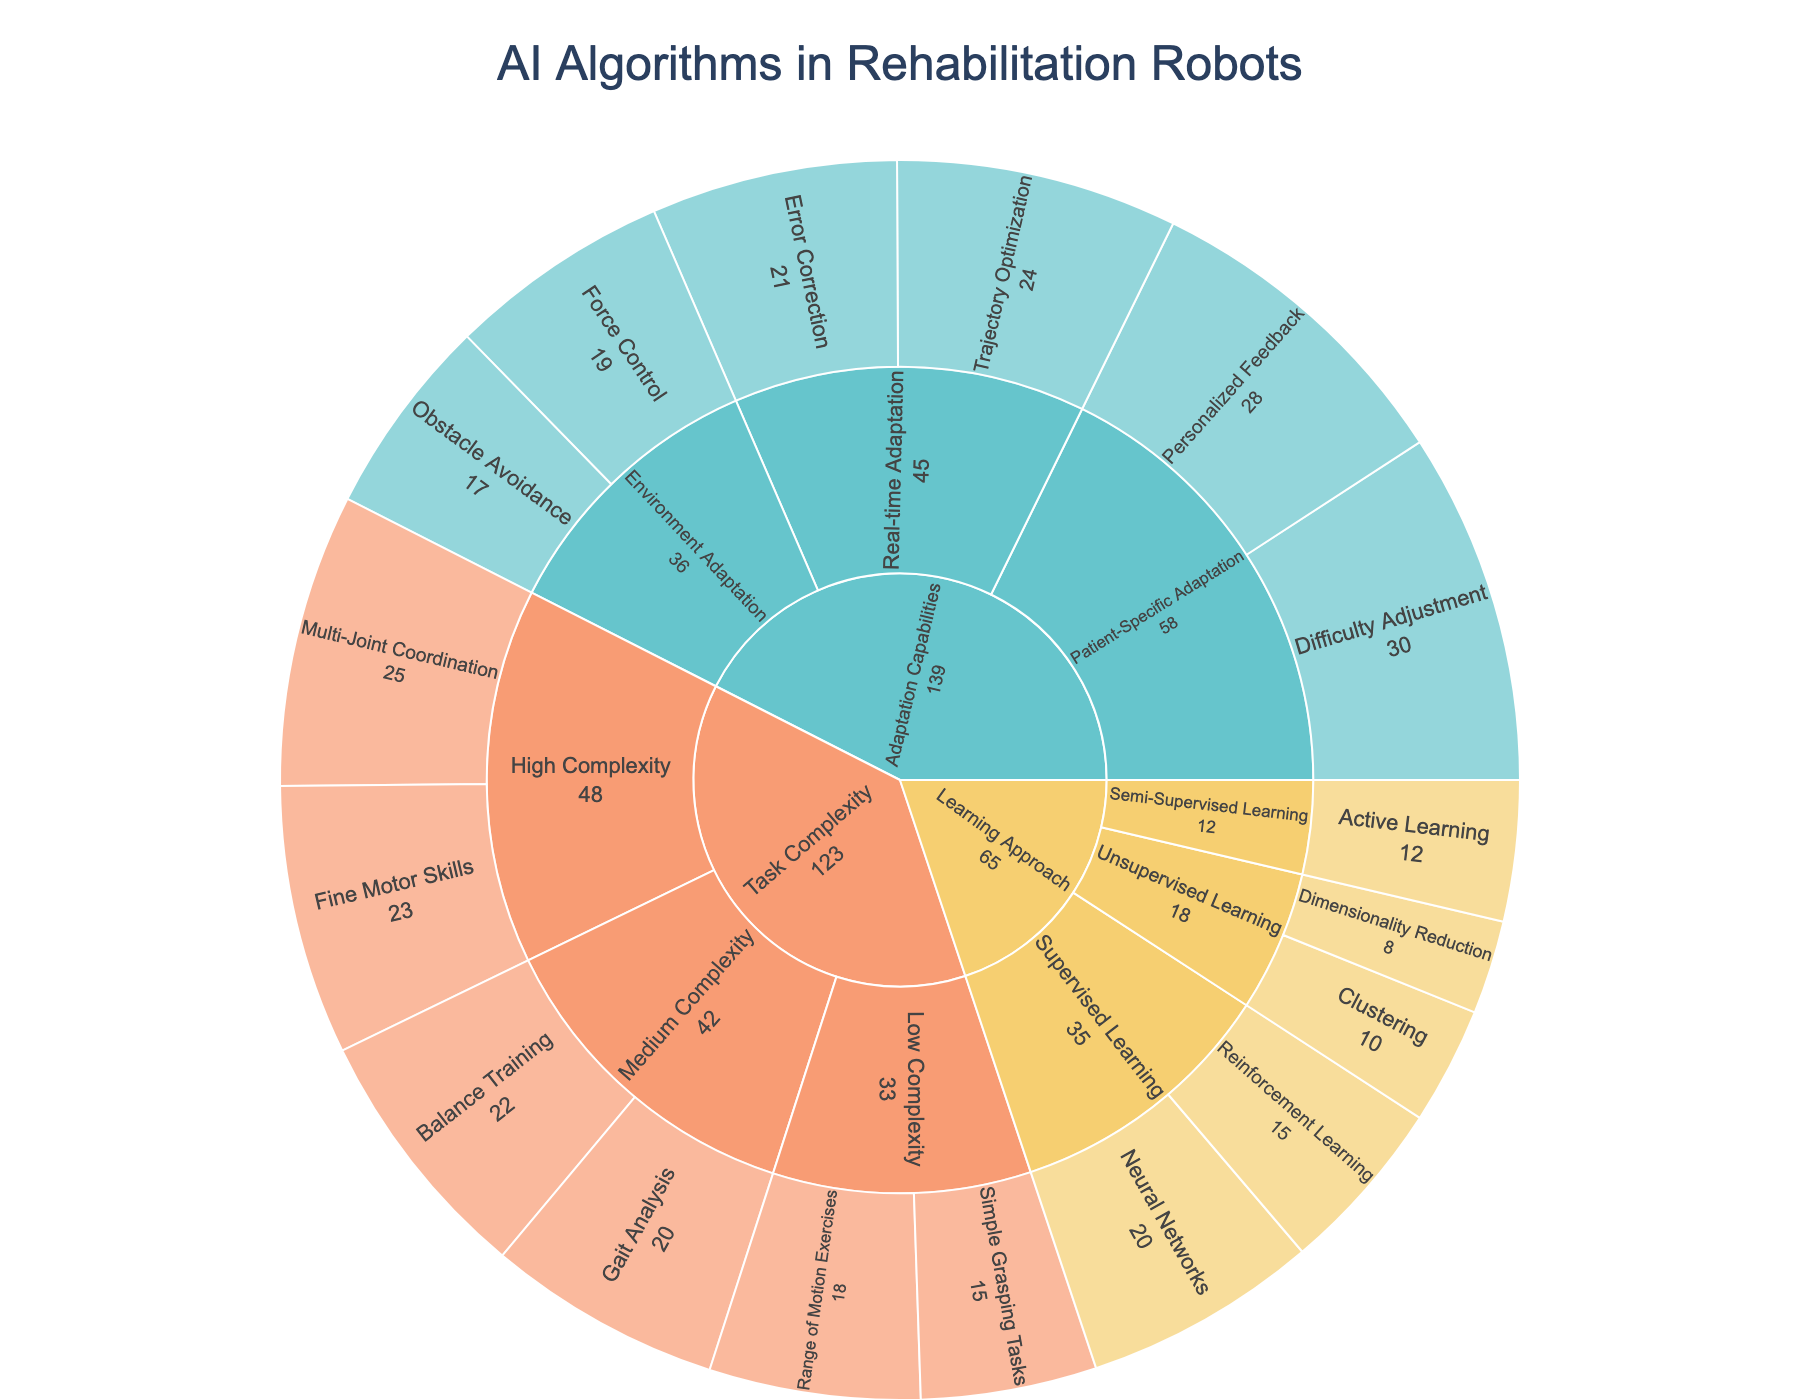How many learning approaches are represented in the plot? The innermost layer of the plot indicates learning approaches. By visually counting, there are three learning approaches: Supervised Learning, Unsupervised Learning, and Semi-Supervised Learning.
Answer: 3 Which subcategory within Task Complexity has the highest value, and what is the value? For Task Complexity, the categories are Low Complexity, Medium Complexity, and High Complexity. Within each of these, we identify subcategories. By comparing their values, High Complexity's Multi-Joint Coordination has the highest value of 25.
Answer: Multi-Joint Coordination, 25 What is the total value for Patient-Specific Adaptation within Adaptation Capabilities? Patient-Specific Adaptation includes Difficulty Adjustment and Personalized Feedback. By summing their values (30 + 28), the total is 58.
Answer: 58 Compare the values of Obstacle Avoidance and Force Control in terms of Environment Adaptation. Which one is higher and by how much? Within Environment Adaptation, Obstacle Avoidance has a value of 17 and Force Control has a value of 19. The difference is 19 - 17, which means Force Control is higher by 2.
Answer: Force Control by 2 Which learning approach has the highest combined value of its subcategories, and what is the total value? Add up the values of subcategories for each learning approach:
Supervised Learning (15 + 20 = 35), Unsupervised Learning (10 + 8 = 18), Semi-Supervised Learning (12). 
The highest combined value is for Supervised Learning, totaling 35.
Answer: Supervised Learning, 35 How do the values of Error Correction and Trajectory Optimization compare in terms of Real-time Adaptation? Within Real-time Adaptation, the subcategories Error Correction has a value of 21 and Trajectory Optimization has 24. Trajectory Optimization has a higher value by 3.
Answer: Trajectory Optimization by 3 Which Adaptation Capabilities subcategory has the lowest value and what is it? By examining the subcategories within Adaptation Capabilities, Obstacle Avoidance has the lowest value of 17.
Answer: Obstacle Avoidance, 17 What is the average value for the learning approaches? The values for different learning approaches are 35 for Supervised Learning, 18 for Unsupervised Learning, and 12 for Semi-Supervised Learning. The average is (35 + 18 + 12) / 3 = 65 / 3 ≈ 21.67.
Answer: 21.67 What's the percentage contribution of Range of Motion Exercises to the total value of Task Complexity? First, find the total value for Task Complexity by summing all subcategory values (18 + 15 + 22 + 20 + 25 + 23 = 123). Then, calculate the percentage for Range of Motion Exercises, which is (18 / 123) * 100 ≈ 14.63%.
Answer: 14.63% Which subcategory has the highest value within the entire plot? By examining all subcategories in detail, Difficulty Adjustment has the highest value of 30 within Patient-Specific Adaptation.
Answer: Difficulty Adjustment, 30 